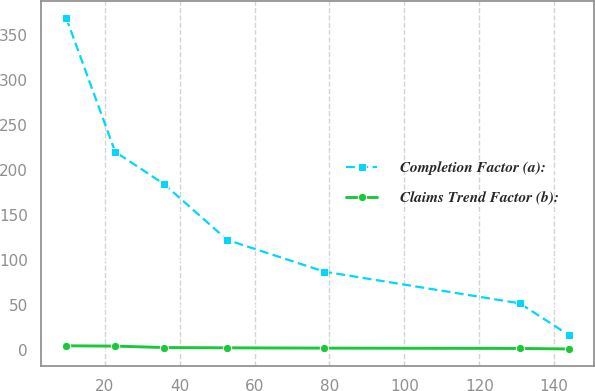<chart> <loc_0><loc_0><loc_500><loc_500><line_chart><ecel><fcel>Completion Factor (a):<fcel>Claims Trend Factor (b):<nl><fcel>9.7<fcel>368.67<fcel>4.99<nl><fcel>22.79<fcel>220.01<fcel>4.67<nl><fcel>35.88<fcel>184.13<fcel>3.07<nl><fcel>52.69<fcel>122.38<fcel>2.75<nl><fcel>78.64<fcel>87.2<fcel>2.43<nl><fcel>130.85<fcel>52.02<fcel>2.07<nl><fcel>143.94<fcel>16.84<fcel>1.49<nl></chart> 